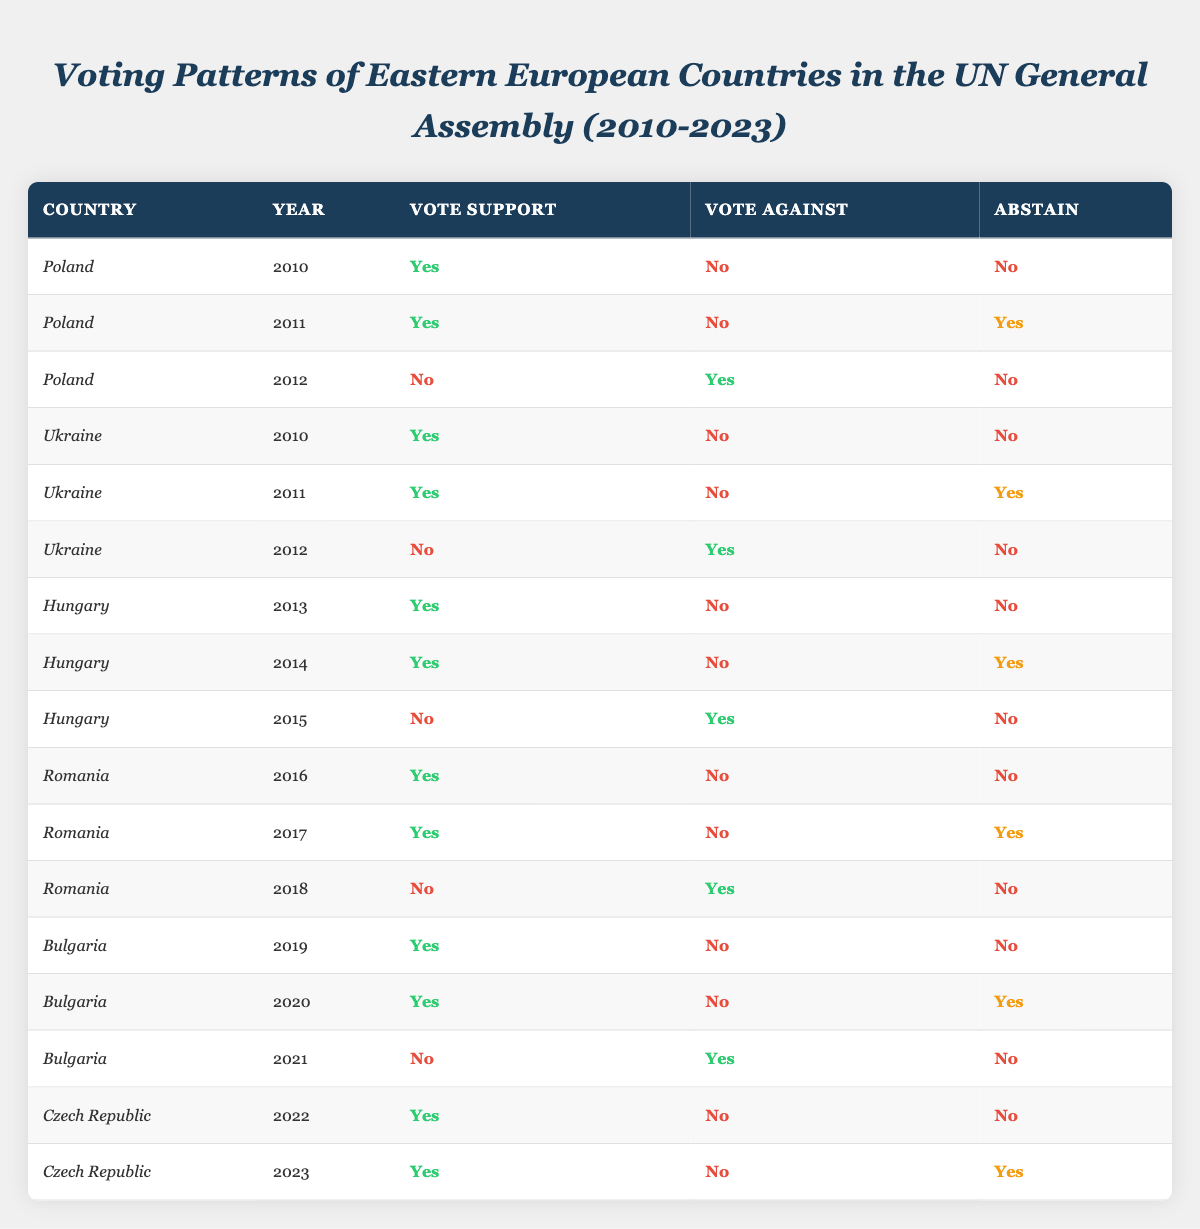What was Poland's voting pattern in 2010? In 2010, Poland voted "Yes" in support, did not vote against, and did not abstain from the vote.
Answer: Yes, No, No How many times did Hungary vote against in the years provided? Hungary voted against in 2015, resulting in 1 time it voted "Yes".
Answer: 1 Did Romania ever abstain in the voting years provided? Yes, Romania abstained in the years 2011 and 2017.
Answer: Yes What was the voting outcome for Bulgaria in 2021? In 2021, Bulgaria voted "No" against, did not vote "Yes" in support, and did not abstain.
Answer: No How many times did Ukraine support a vote from 2010 to 2012? In 2010 and 2011, Ukraine voted "Yes", making it a total of 2 supportive votes out of 3 years.
Answer: 2 Which country had the most "Abstain" votes in the provided data? Romania and Hungary both had 2 instances of abstaining votes over the years, making it equal for both.
Answer: Romania, Hungary What voting pattern did the Czech Republic show in 2022? The Czech Republic voted "Yes" for support, did not vote against, and did not abstain in 2022.
Answer: Yes, No, No Did any country show a consistent pattern of voting "Yes" from 2010 to 2023? No country voted "Yes" every year; all countries had variations in their voting patterns.
Answer: No What was the trend for Poland's voting from 2010 to 2012? Poland supported votes in 2010 and 2011 but voted against in 2012.
Answer: Mixed trend What is the average occurrence of "Yes" votes among the Eastern European countries listed? The total number of "Yes" votes across all entries is 11 in 15 votes counted, leading to an average of 0.73 or approximately 73%.
Answer: 73% 